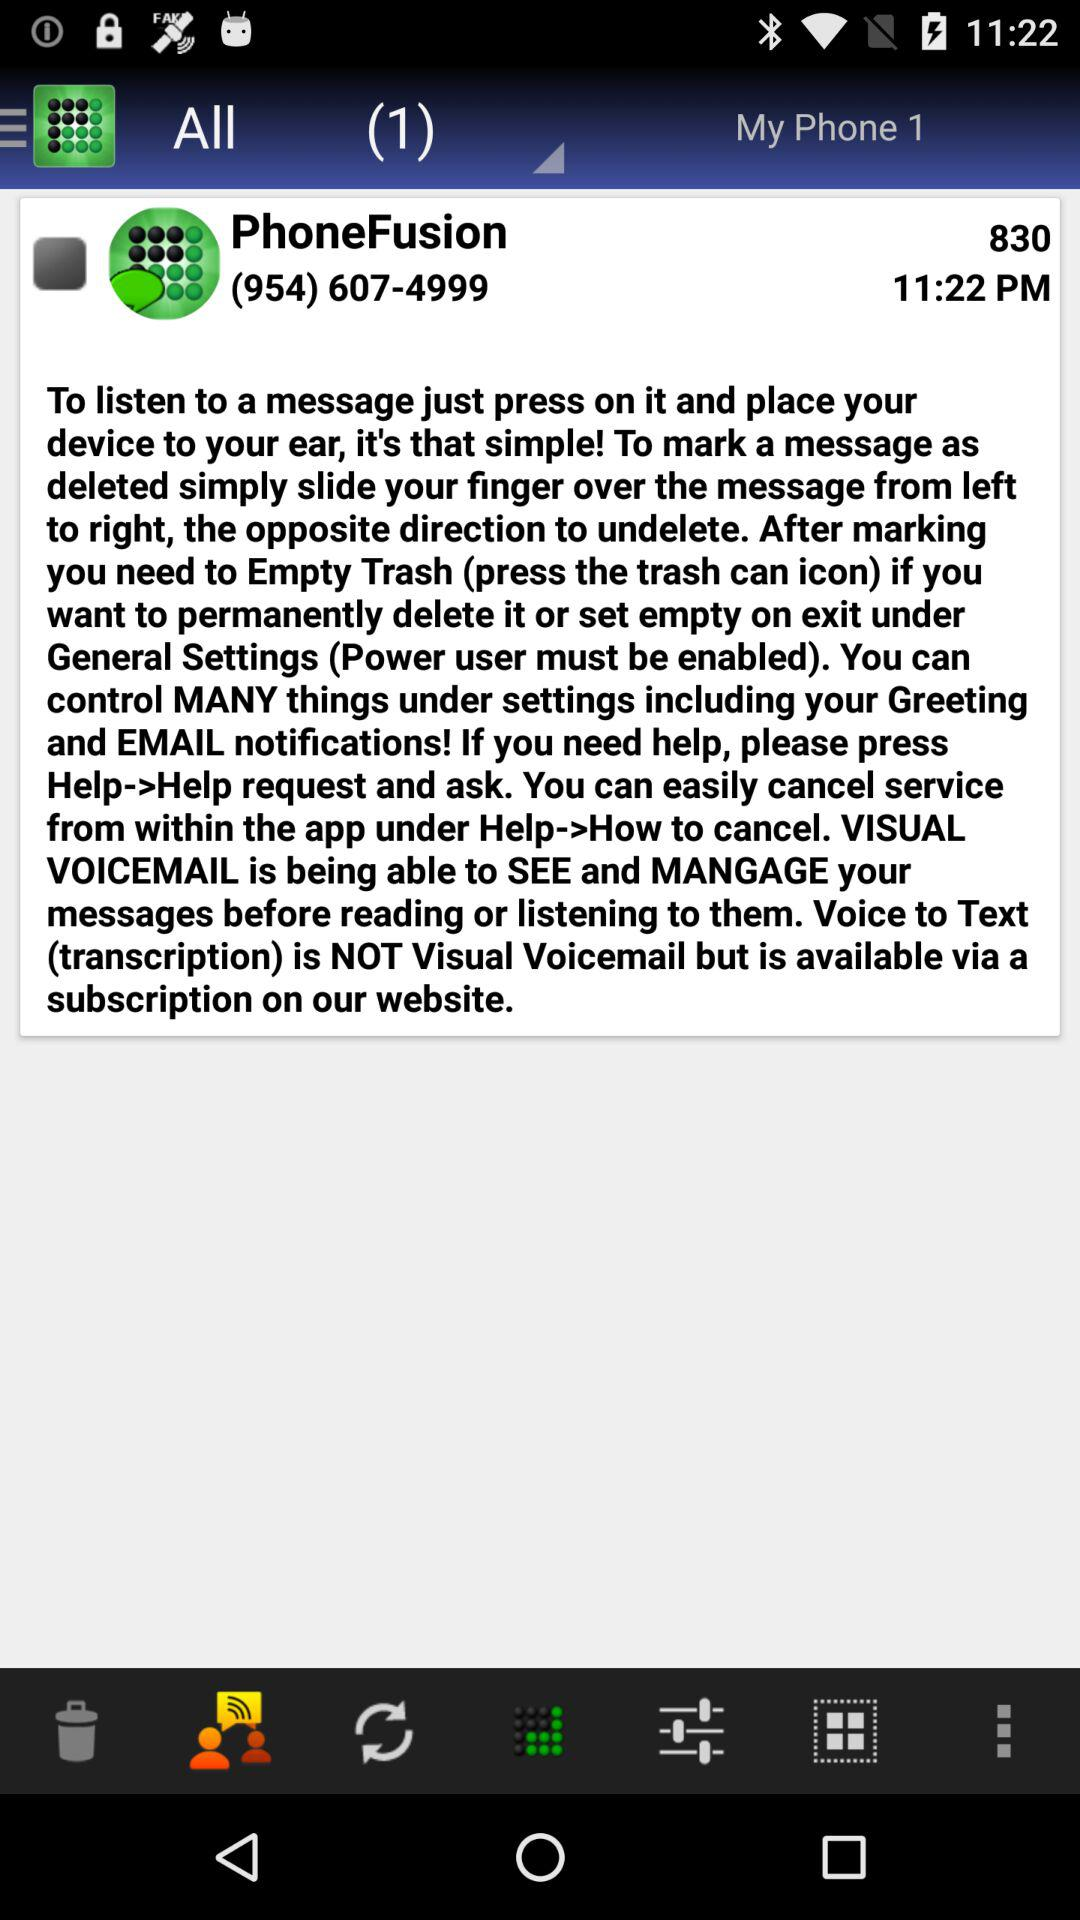What is the mentioned time? The mentioned time is 11:22 p.m. 